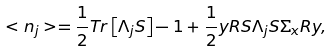Convert formula to latex. <formula><loc_0><loc_0><loc_500><loc_500>< n _ { j } > = \frac { 1 } { 2 } T r \left [ \Lambda _ { j } { S } \right ] - 1 + \frac { 1 } { 2 } { y } { R } { S } \Lambda _ { j } { S } \Sigma _ { x } { R } { y } ,</formula> 